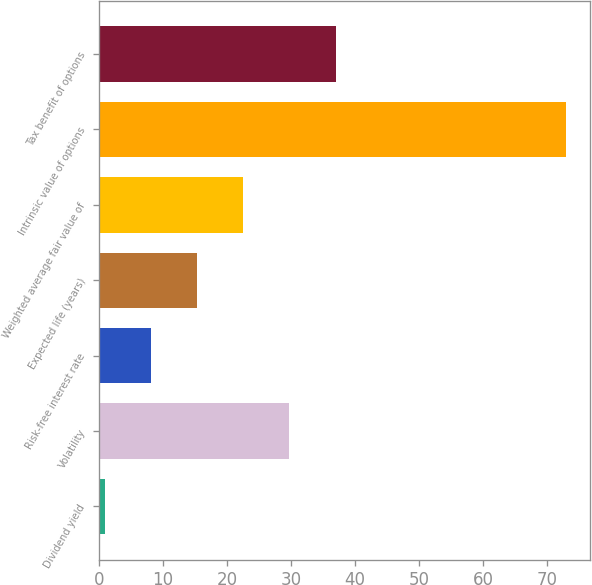Convert chart. <chart><loc_0><loc_0><loc_500><loc_500><bar_chart><fcel>Dividend yield<fcel>Volatility<fcel>Risk-free interest rate<fcel>Expected life (years)<fcel>Weighted average fair value of<fcel>Intrinsic value of options<fcel>Tax benefit of options<nl><fcel>0.9<fcel>29.74<fcel>8.11<fcel>15.32<fcel>22.53<fcel>73<fcel>36.95<nl></chart> 